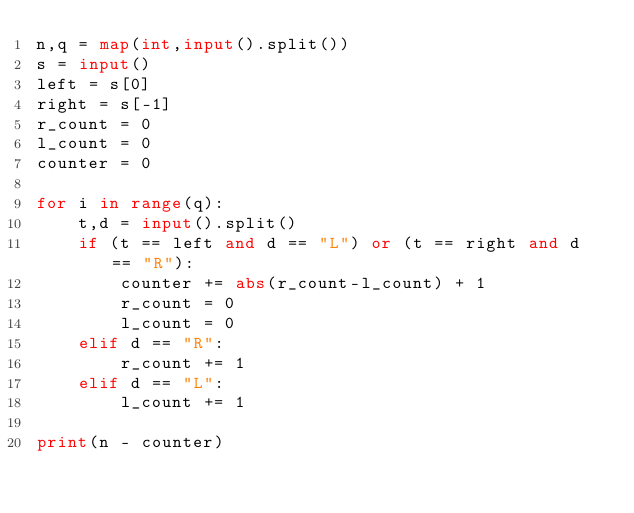Convert code to text. <code><loc_0><loc_0><loc_500><loc_500><_Python_>n,q = map(int,input().split())
s = input()
left = s[0]
right = s[-1]
r_count = 0
l_count = 0
counter = 0

for i in range(q):
    t,d = input().split()
    if (t == left and d == "L") or (t == right and d == "R"):
        counter += abs(r_count-l_count) + 1
        r_count = 0
        l_count = 0
    elif d == "R":
        r_count += 1
    elif d == "L":
        l_count += 1
        
print(n - counter)</code> 